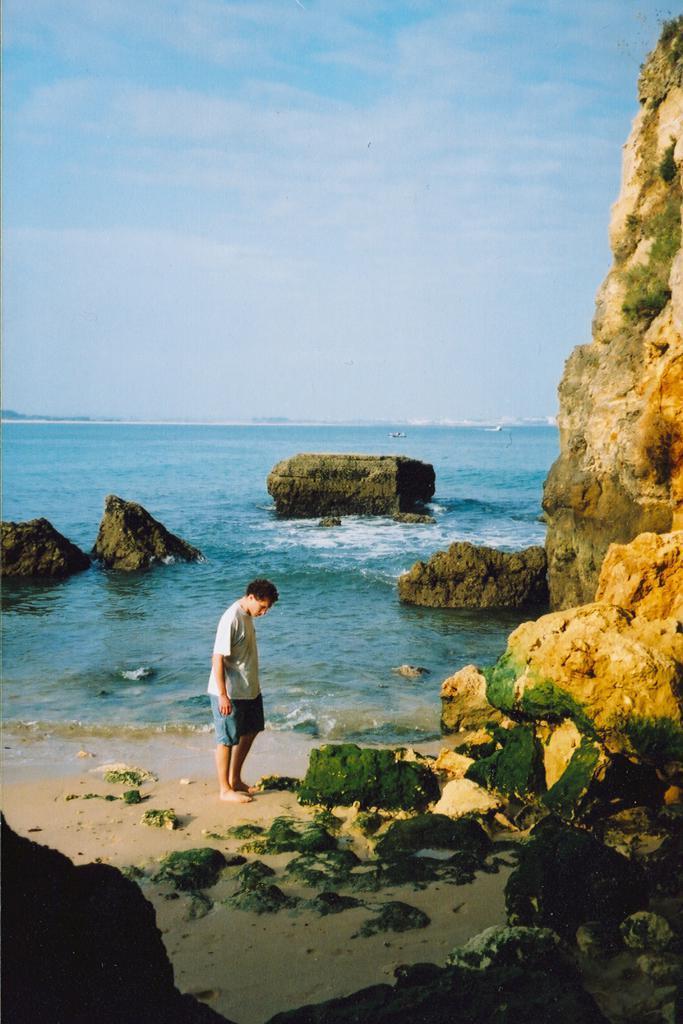Describe this image in one or two sentences. In the picture we can see the part of the rock hill and beside it we can see some stones with mold to it on the sand surface and near it we can see a person standing and behind the person we can see water surface and in the water we can see some rocks and in the background we can see the sky with clouds. 